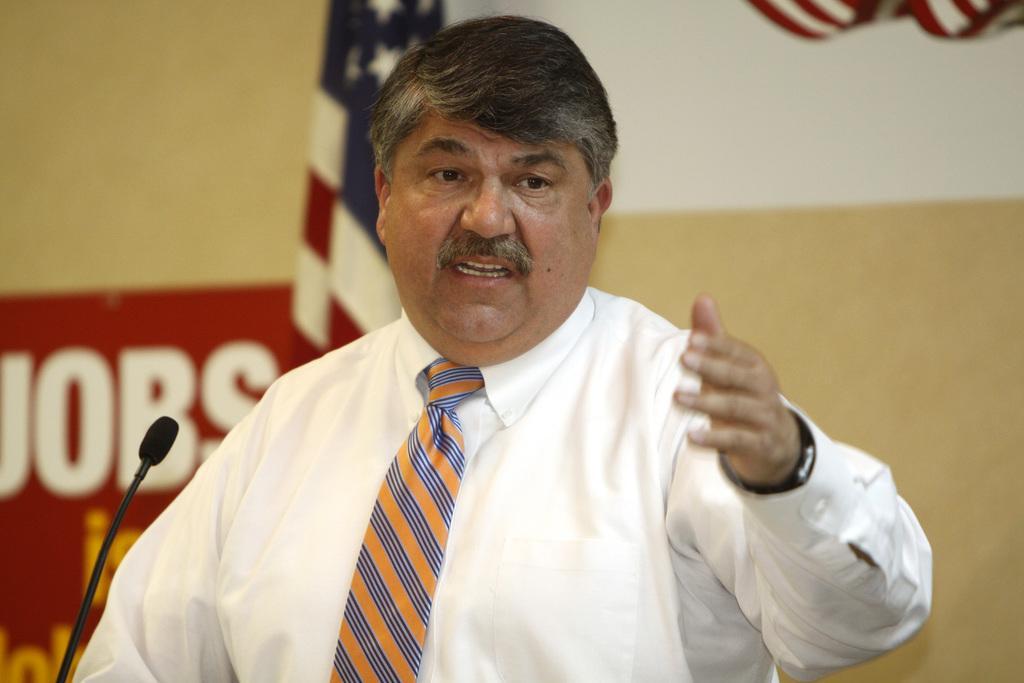How would you summarize this image in a sentence or two? In this picture I can observe a man wearing white color shirt and a tie. In front of him there is a mic. Behind him I can observe a national flag. In the background there is a wall which is in cream color. 